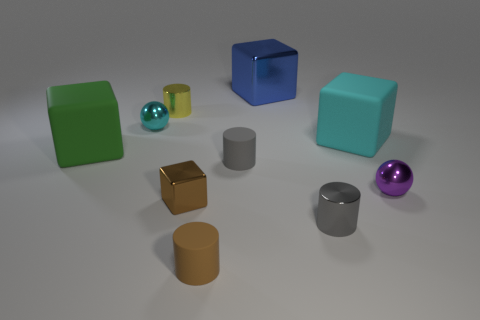What number of blocks are small blue shiny things or gray things?
Give a very brief answer. 0. There is a large metallic thing; is its shape the same as the small object behind the cyan metallic ball?
Your response must be concise. No. Is the number of big green cubes behind the blue metallic cube less than the number of large green rubber cubes?
Your response must be concise. Yes. There is a yellow thing; are there any small gray objects in front of it?
Provide a succinct answer. Yes. Are there any gray matte objects of the same shape as the big blue object?
Provide a short and direct response. No. There is a gray matte object that is the same size as the purple sphere; what shape is it?
Offer a very short reply. Cylinder. What number of objects are either gray cylinders that are to the right of the large metal object or metallic cubes?
Give a very brief answer. 3. There is a cube on the right side of the blue block; what size is it?
Keep it short and to the point. Large. Are there any gray matte spheres of the same size as the brown cube?
Give a very brief answer. No. There is a gray metal cylinder in front of the brown shiny cube; does it have the same size as the cyan cube?
Provide a short and direct response. No. 